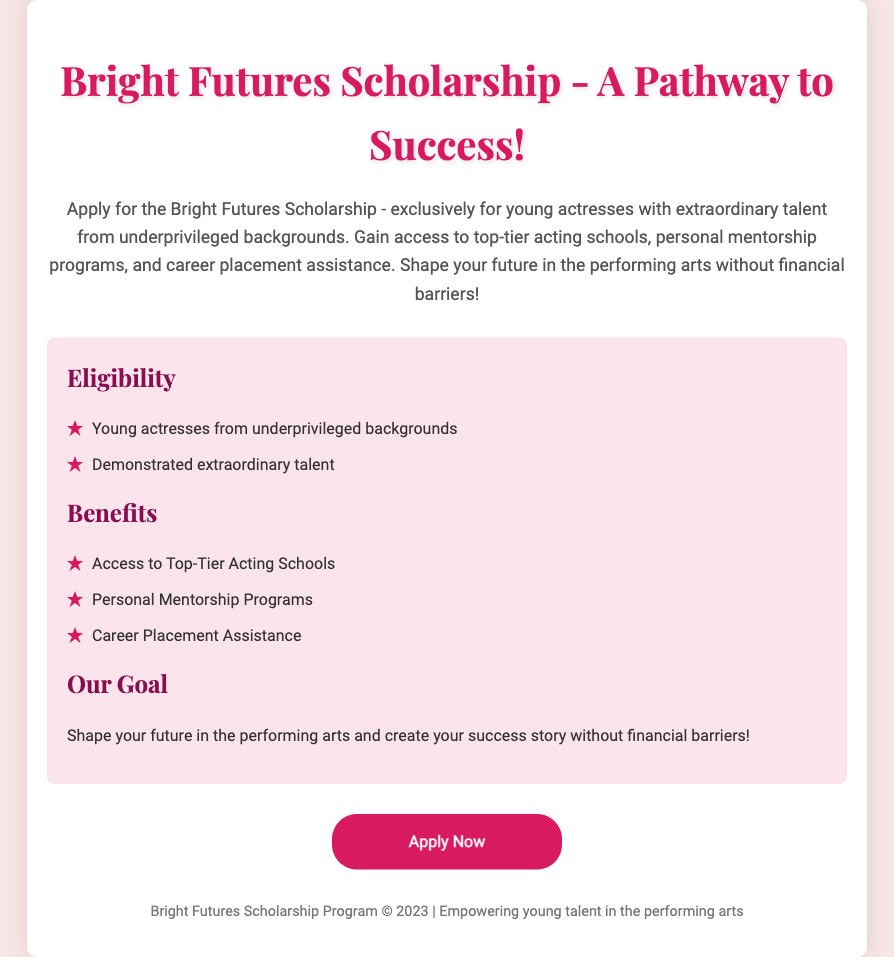What is the name of the scholarship? The document explicitly states the scholarship's name at the beginning of the description.
Answer: Bright Futures Scholarship Who is eligible to apply? The eligibility criteria are outlined in the section titled "Eligibility," specifically mentioning the target group.
Answer: Young actresses from underprivileged backgrounds What are the benefits of the scholarship? The benefits are listed under the "Benefits" section, summarizing what the scholarship offers to recipients.
Answer: Access to Top-Tier Acting Schools What type of programs are included in the scholarship? The document provides specific examples of programs included in the benefits section.
Answer: Personal Mentorship Programs What is the main goal of the scholarship? The main goal is stated clearly at the end of the "Our Goal" section.
Answer: Shape your future in the performing arts What year was the scholarship program established? The footer of the document gives the year of the program's mention, which is a common detail for advertisements.
Answer: 2023 What action should interested applicants take? The conclusion includes a call to action guiding readers on what to do next regarding the scholarship.
Answer: Apply Now How is talent defined for the scholarship? The document explains the required talent criteria in the eligibility section, emphasizing the quality recognized.
Answer: Demonstrated extraordinary talent What theme does the scholarship focus on? The overarching theme is captured in the scholarship's description, emphasizing empowerment and opportunity.
Answer: Empowering young talent in the performing arts 